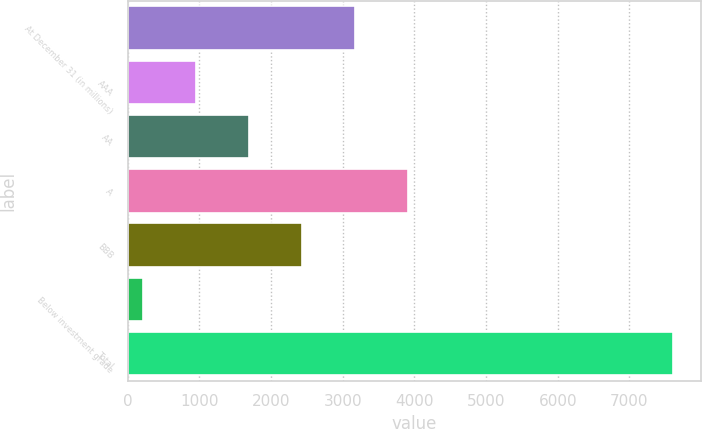Convert chart. <chart><loc_0><loc_0><loc_500><loc_500><bar_chart><fcel>At December 31 (in millions)<fcel>AAA<fcel>AA<fcel>A<fcel>BBB<fcel>Below investment grade<fcel>Total<nl><fcel>3172.6<fcel>952.9<fcel>1692.8<fcel>3912.5<fcel>2432.7<fcel>213<fcel>7612<nl></chart> 